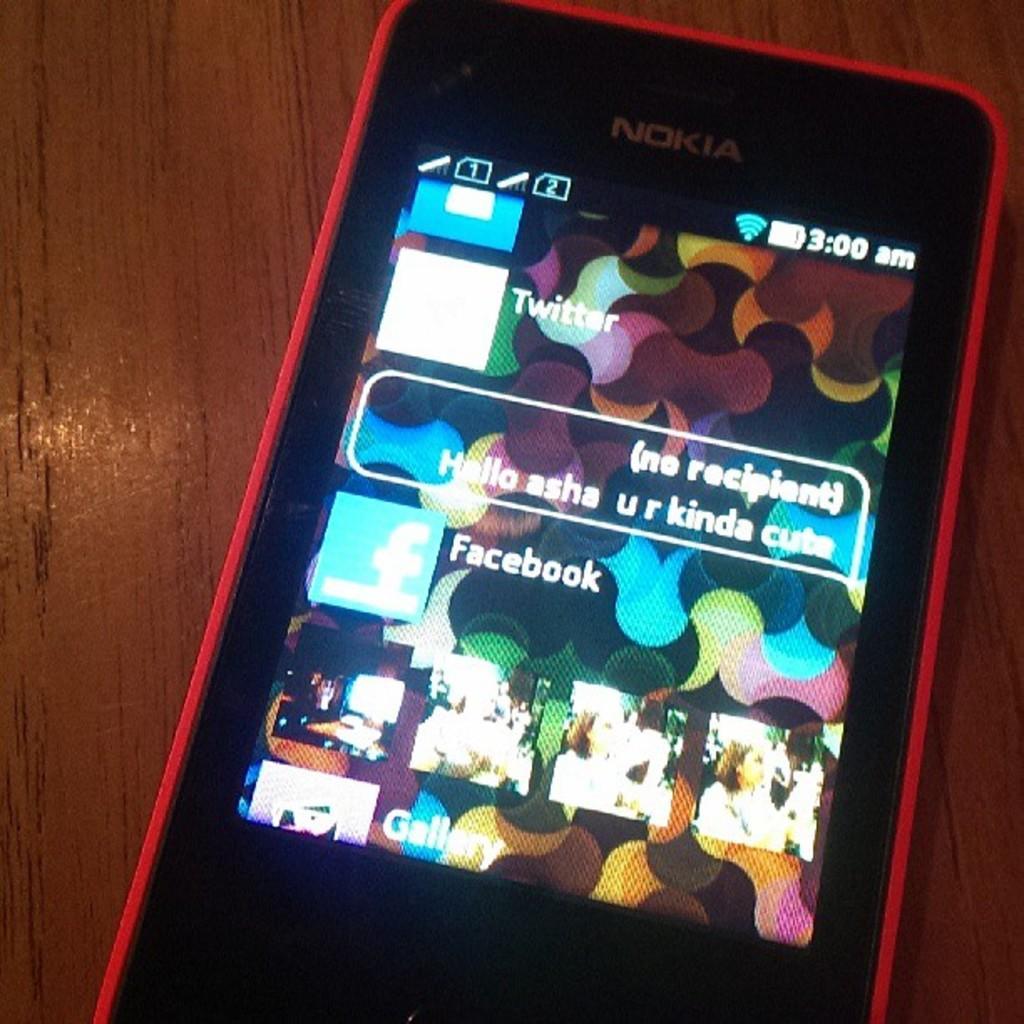Please provide a concise description of this image. In this image we can see a phone on the wooden surface. 